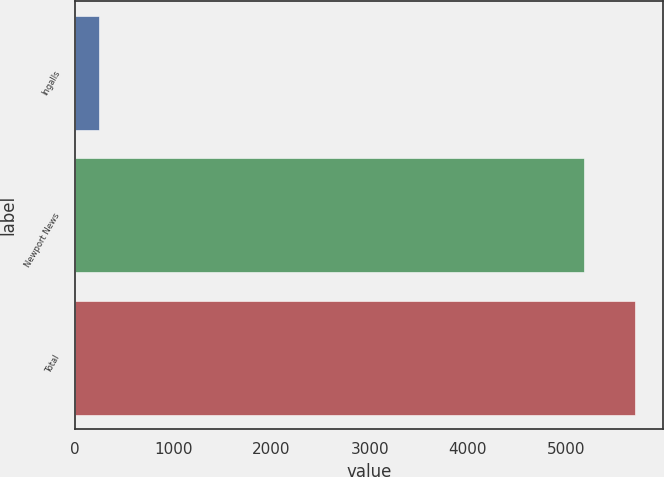Convert chart. <chart><loc_0><loc_0><loc_500><loc_500><bar_chart><fcel>Ingalls<fcel>Newport News<fcel>Total<nl><fcel>242<fcel>5185<fcel>5703.5<nl></chart> 